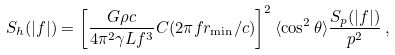Convert formula to latex. <formula><loc_0><loc_0><loc_500><loc_500>S _ { h } ( | f | ) = \left [ \frac { G \rho c } { 4 \pi ^ { 2 } \gamma L f ^ { 3 } } C ( 2 \pi f r _ { \min } / c ) \right ] ^ { 2 } \langle \cos ^ { 2 } \theta \rangle \frac { S _ { p } ( | f | ) } { p ^ { 2 } } \, ,</formula> 